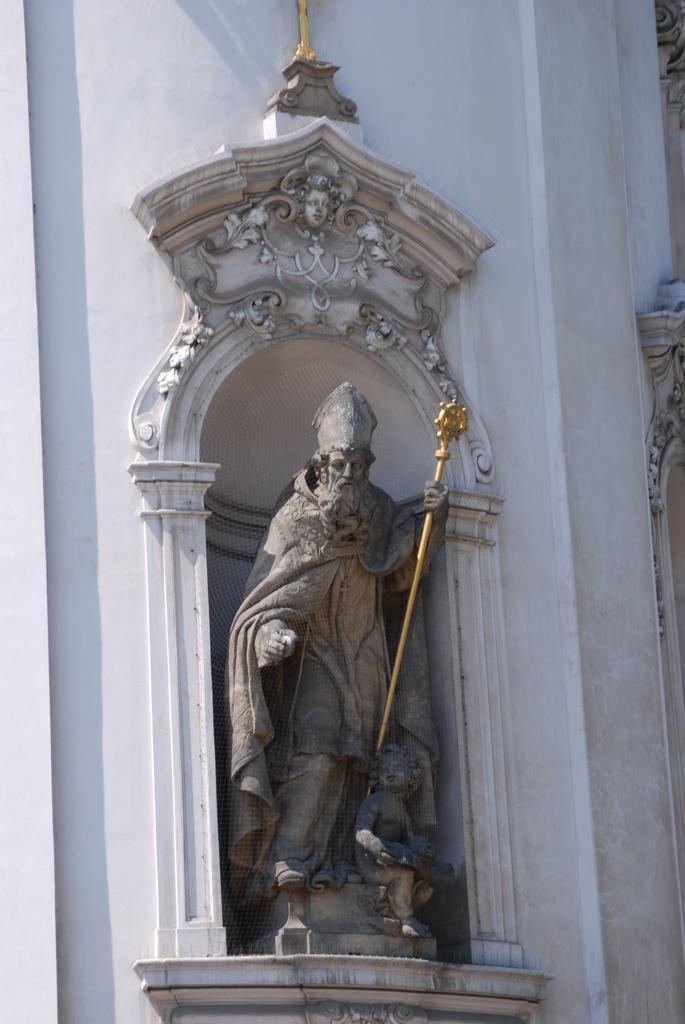In one or two sentences, can you explain what this image depicts? In this image I can see a statue of the person holding the gold color object and the statue is attached to the wall and the wall is in white color. 